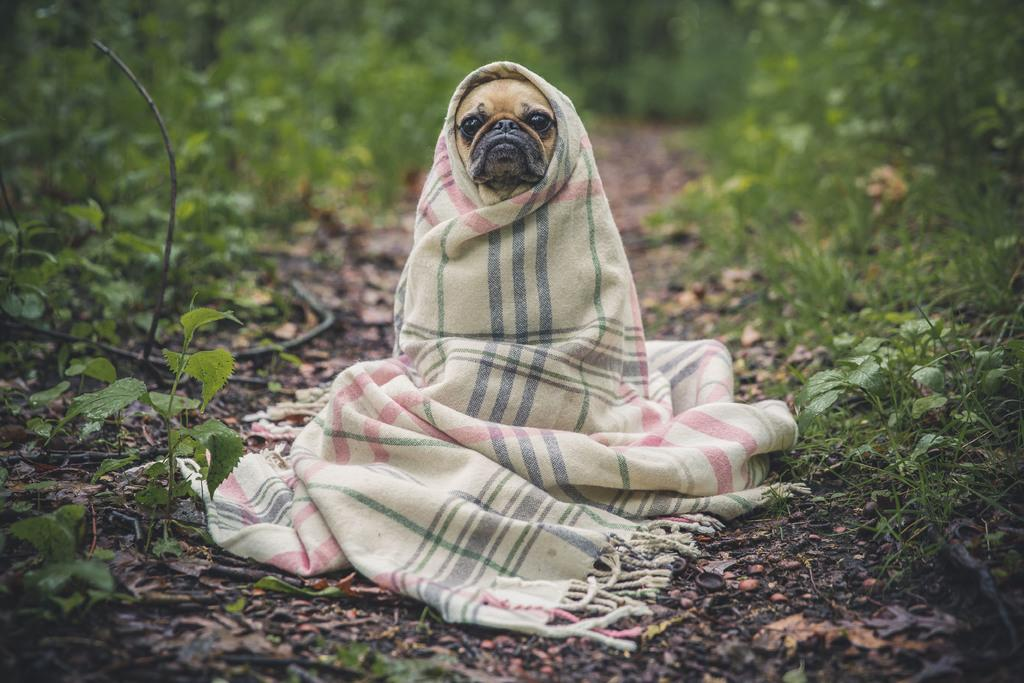What type of animal is in the image? There is a puppy in the image. How is the puppy positioned in the image? The puppy is wrapped in a towel and on the ground. What can be seen in the background of the image? There are plants and grass in the background of the image. What type of jelly is the puppy eating in the image? There is no jelly present in the image; the puppy is wrapped in a towel and on the ground. 